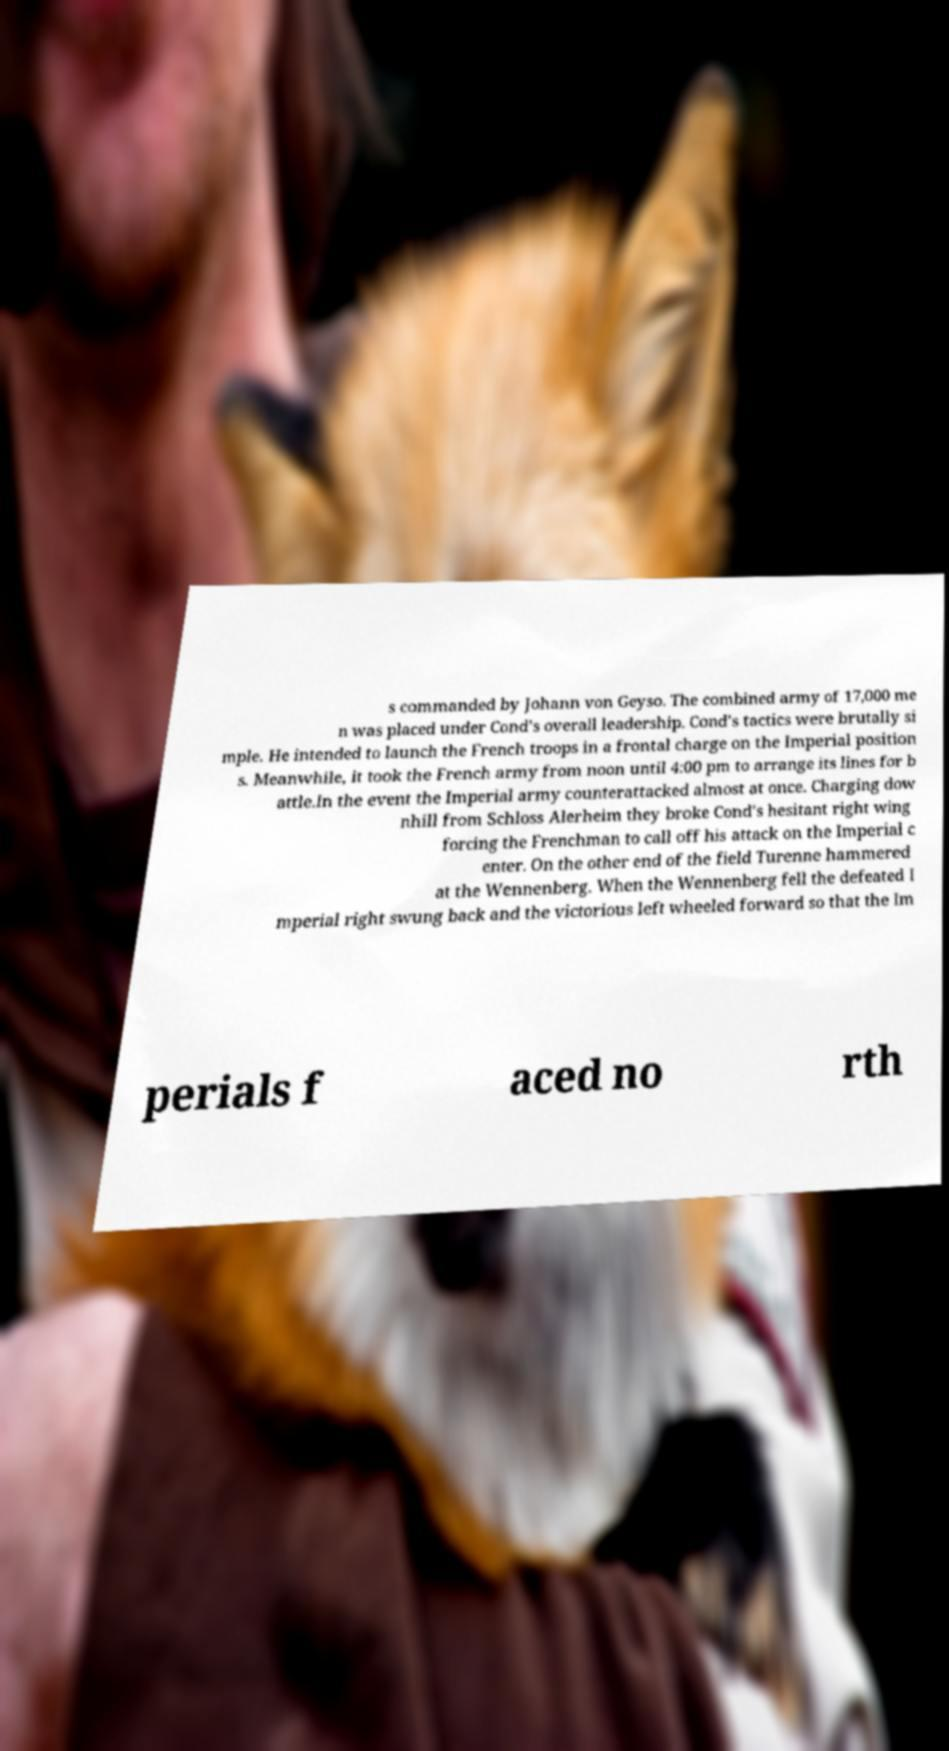Please read and relay the text visible in this image. What does it say? s commanded by Johann von Geyso. The combined army of 17,000 me n was placed under Cond's overall leadership. Cond's tactics were brutally si mple. He intended to launch the French troops in a frontal charge on the Imperial position s. Meanwhile, it took the French army from noon until 4:00 pm to arrange its lines for b attle.In the event the Imperial army counterattacked almost at once. Charging dow nhill from Schloss Alerheim they broke Cond's hesitant right wing forcing the Frenchman to call off his attack on the Imperial c enter. On the other end of the field Turenne hammered at the Wennenberg. When the Wennenberg fell the defeated I mperial right swung back and the victorious left wheeled forward so that the Im perials f aced no rth 